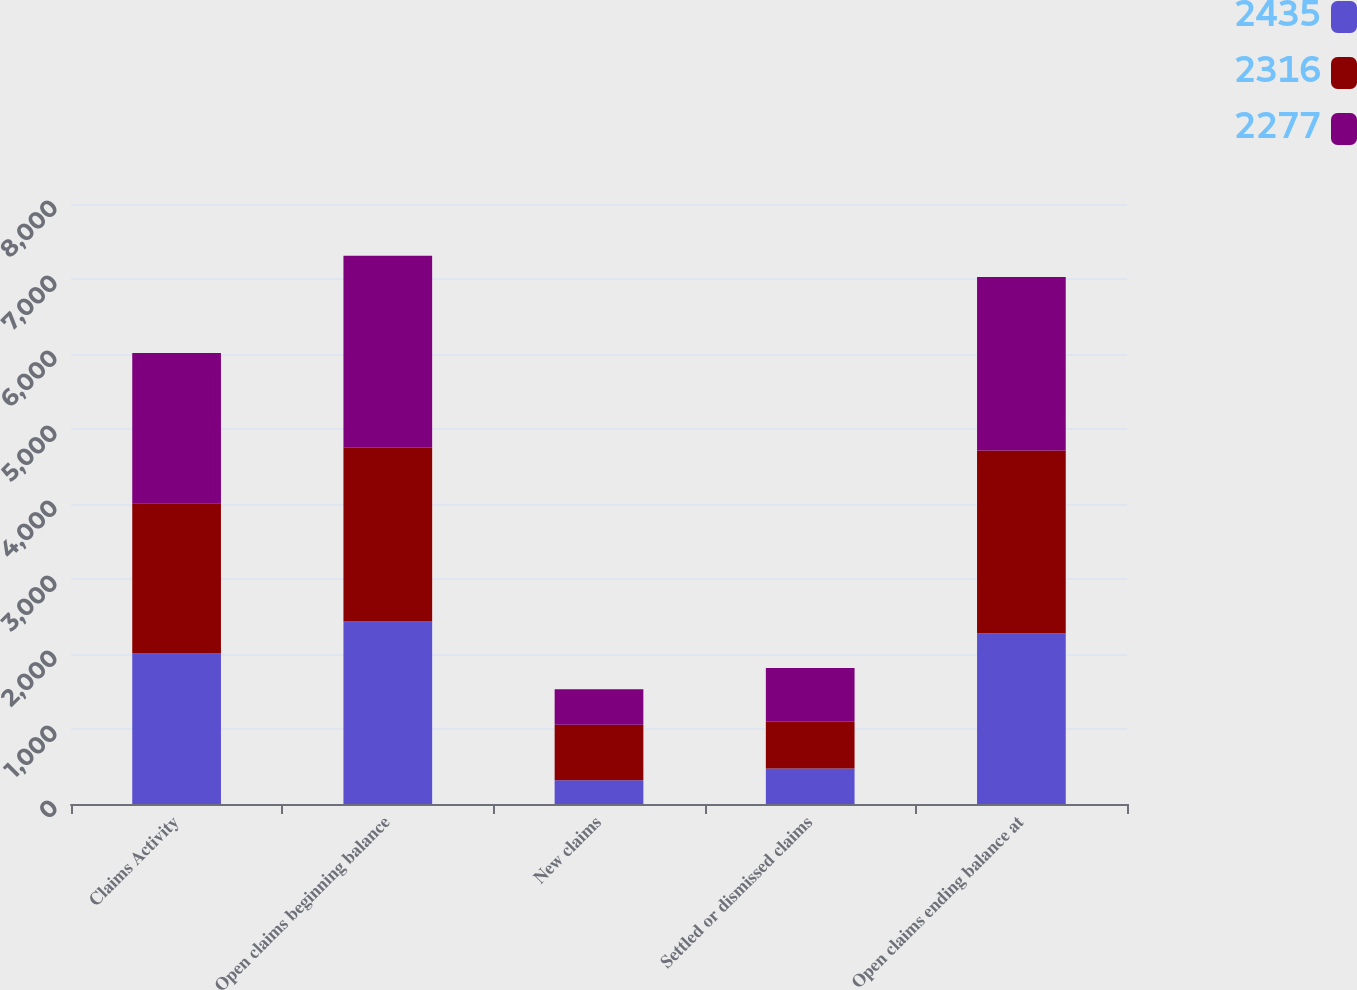Convert chart to OTSL. <chart><loc_0><loc_0><loc_500><loc_500><stacked_bar_chart><ecel><fcel>Claims Activity<fcel>Open claims beginning balance<fcel>New claims<fcel>Settled or dismissed claims<fcel>Open claims ending balance at<nl><fcel>2435<fcel>2006<fcel>2435<fcel>316<fcel>474<fcel>2277<nl><fcel>2316<fcel>2005<fcel>2316<fcel>741<fcel>622<fcel>2435<nl><fcel>2277<fcel>2004<fcel>2560<fcel>474<fcel>718<fcel>2316<nl></chart> 